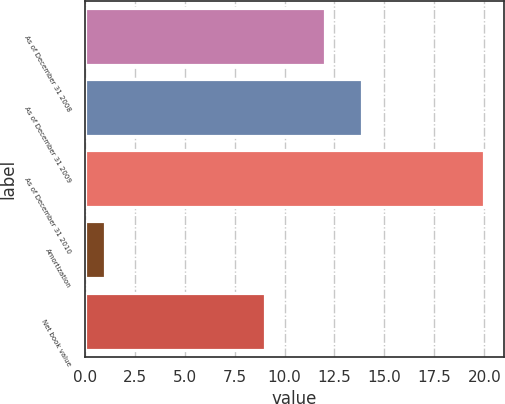Convert chart to OTSL. <chart><loc_0><loc_0><loc_500><loc_500><bar_chart><fcel>As of December 31 2008<fcel>As of December 31 2009<fcel>As of December 31 2010<fcel>Amortization<fcel>Net book value<nl><fcel>12<fcel>13.9<fcel>20<fcel>1<fcel>9<nl></chart> 